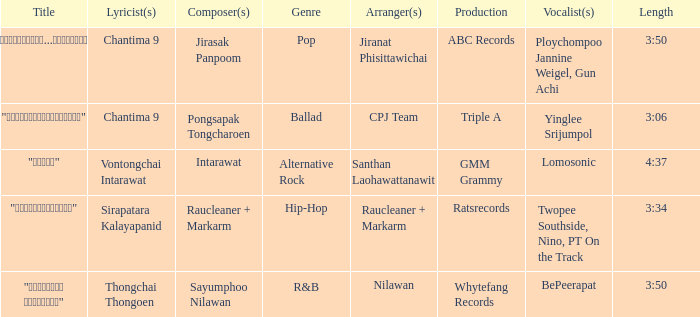Who organized the composition of "ขอโทษ"? Santhan Laohawattanawit. 